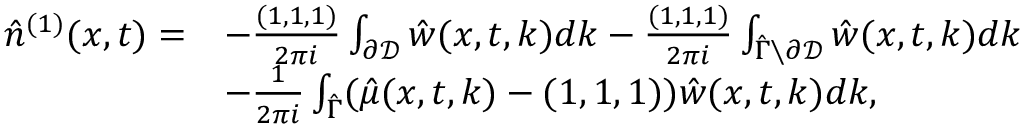Convert formula to latex. <formula><loc_0><loc_0><loc_500><loc_500>\begin{array} { r l } { \hat { n } ^ { ( 1 ) } ( x , t ) = } & { - \frac { ( 1 , 1 , 1 ) } { 2 \pi i } \int _ { \partial \mathcal { D } } \hat { w } ( x , t , k ) d k - \frac { ( 1 , 1 , 1 ) } { 2 \pi i } \int _ { \hat { \Gamma } \ \partial \mathcal { D } } \hat { w } ( x , t , k ) d k } \\ & { - \frac { 1 } { 2 \pi i } \int _ { \hat { \Gamma } } ( \hat { \mu } ( x , t , k ) - ( 1 , 1 , 1 ) ) \hat { w } ( x , t , k ) d k , } \end{array}</formula> 